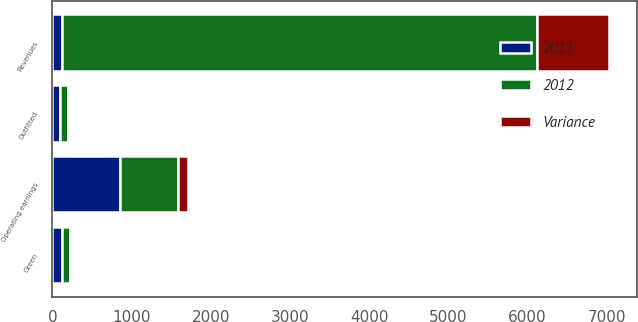Convert chart to OTSL. <chart><loc_0><loc_0><loc_500><loc_500><stacked_bar_chart><ecel><fcel>Revenues<fcel>Operating earnings<fcel>Green<fcel>Outfitted<nl><fcel>2012<fcel>5998<fcel>729<fcel>107<fcel>99<nl><fcel>2011<fcel>121<fcel>858<fcel>121<fcel>94<nl><fcel>Variance<fcel>914<fcel>129<fcel>14<fcel>5<nl></chart> 